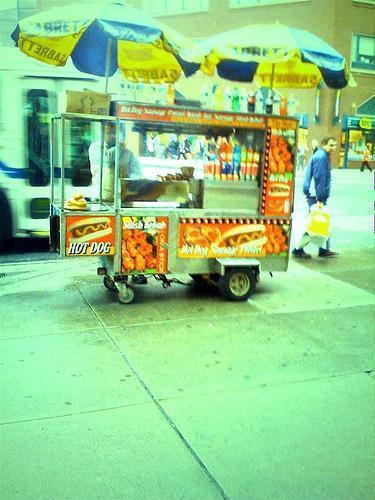How many pictures of hot dogs are visible on the hot dog stand?
Give a very brief answer. 3. How many wheels are on the hot dog stand?
Give a very brief answer. 4. How many umbrellas are on the hot dog cart?
Give a very brief answer. 2. How many umbrellas are on the cart?
Give a very brief answer. 2. How many people are tending the cart?
Give a very brief answer. 1. How many umbrellas are pictured?
Give a very brief answer. 2. How many umbrellas are in the photo?
Give a very brief answer. 2. How many kites are in the image?
Give a very brief answer. 0. 